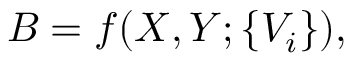<formula> <loc_0><loc_0><loc_500><loc_500>B = f ( X , Y ; \{ V _ { i } \} ) ,</formula> 